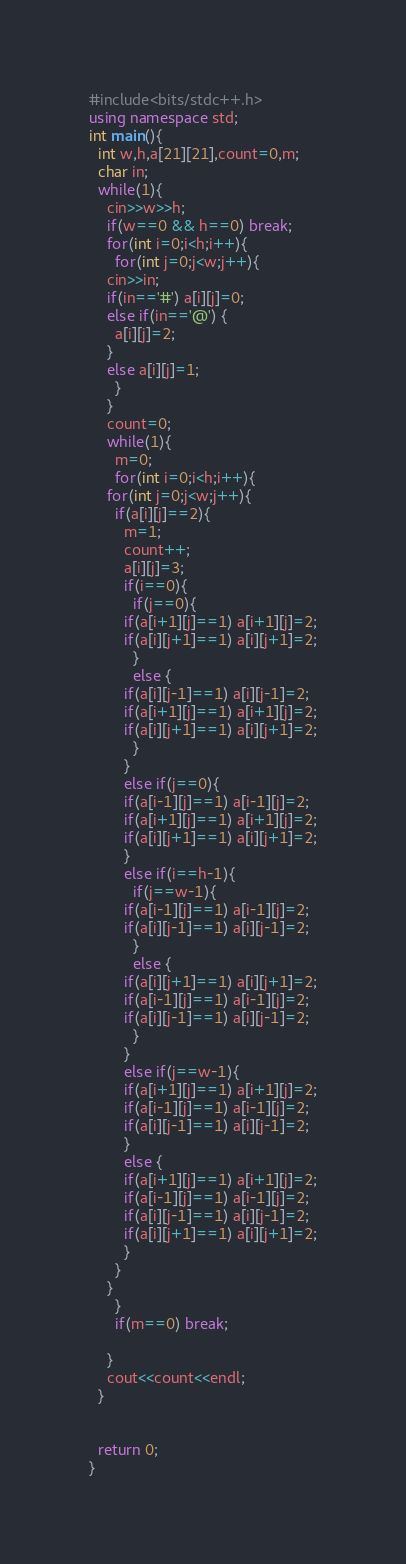<code> <loc_0><loc_0><loc_500><loc_500><_C++_>#include<bits/stdc++.h>
using namespace std;
int main(){
  int w,h,a[21][21],count=0,m;
  char in;
  while(1){
    cin>>w>>h;
    if(w==0 && h==0) break;
    for(int i=0;i<h;i++){
      for(int j=0;j<w;j++){
	cin>>in;
	if(in=='#') a[i][j]=0;
	else if(in=='@') {
	  a[i][j]=2;
	}
	else a[i][j]=1;
      }
    }
    count=0;
    while(1){
      m=0;
      for(int i=0;i<h;i++){
	for(int j=0;j<w;j++){
	  if(a[i][j]==2){
	    m=1;
	    count++;
	    a[i][j]=3;
	    if(i==0){
	      if(j==0){
		if(a[i+1][j]==1) a[i+1][j]=2;
		if(a[i][j+1]==1) a[i][j+1]=2;
	      }
	      else {
		if(a[i][j-1]==1) a[i][j-1]=2;
		if(a[i+1][j]==1) a[i+1][j]=2;
		if(a[i][j+1]==1) a[i][j+1]=2;
	      }
	    }
	    else if(j==0){
		if(a[i-1][j]==1) a[i-1][j]=2;
		if(a[i+1][j]==1) a[i+1][j]=2;
		if(a[i][j+1]==1) a[i][j+1]=2;
	    }
	    else if(i==h-1){
	      if(j==w-1){
		if(a[i-1][j]==1) a[i-1][j]=2;
		if(a[i][j-1]==1) a[i][j-1]=2;
	      }
	      else {
		if(a[i][j+1]==1) a[i][j+1]=2;
		if(a[i-1][j]==1) a[i-1][j]=2;
		if(a[i][j-1]==1) a[i][j-1]=2;
	      }
	    }
	    else if(j==w-1){
		if(a[i+1][j]==1) a[i+1][j]=2;
		if(a[i-1][j]==1) a[i-1][j]=2;
		if(a[i][j-1]==1) a[i][j-1]=2;
	    }
	    else {
		if(a[i+1][j]==1) a[i+1][j]=2;
		if(a[i-1][j]==1) a[i-1][j]=2;
		if(a[i][j-1]==1) a[i][j-1]=2;
		if(a[i][j+1]==1) a[i][j+1]=2;
	    }
	  }
	}
      }
      if(m==0) break;
      
    }
    cout<<count<<endl;
  }
    
    
  return 0;
}

</code> 